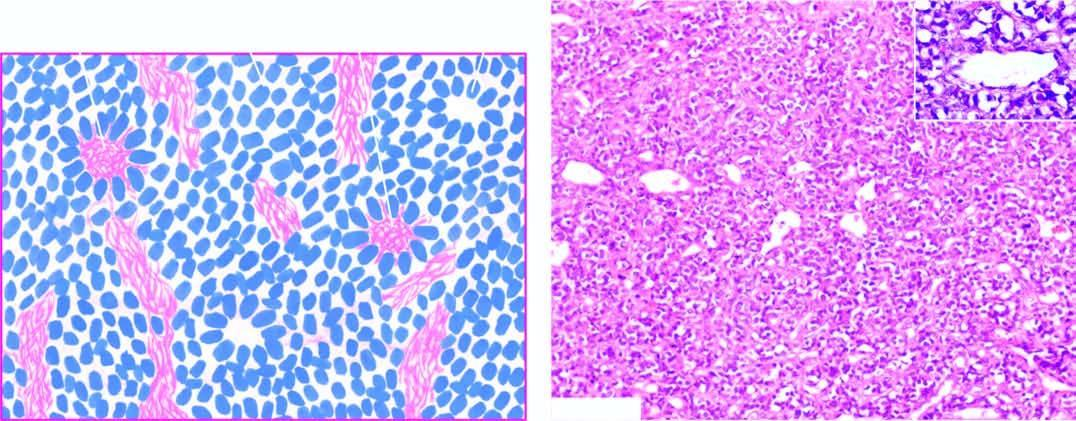does inset show a close-up view of pseudorosette?
Answer the question using a single word or phrase. Yes 